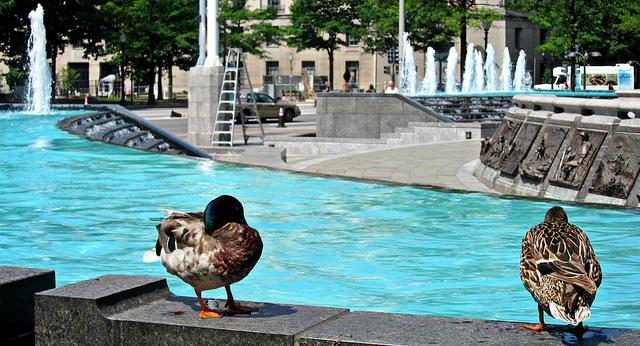Why are they here?

Choices:
A) like water
B) are lost
C) are resting
D) are stuck like water 